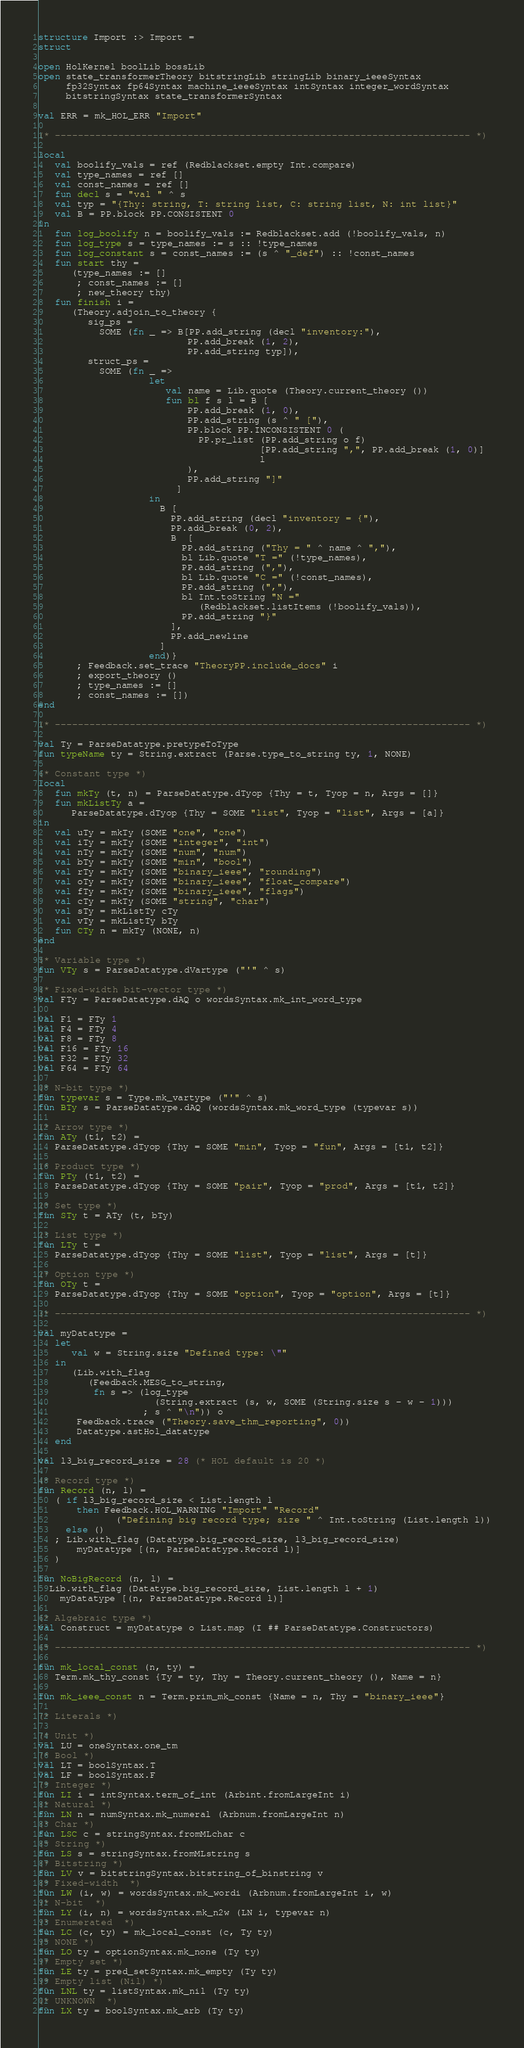Convert code to text. <code><loc_0><loc_0><loc_500><loc_500><_SML_>structure Import :> Import =
struct

open HolKernel boolLib bossLib
open state_transformerTheory bitstringLib stringLib binary_ieeeSyntax
     fp32Syntax fp64Syntax machine_ieeeSyntax intSyntax integer_wordSyntax
     bitstringSyntax state_transformerSyntax

val ERR = mk_HOL_ERR "Import"

(* ------------------------------------------------------------------------ *)

local
   val boolify_vals = ref (Redblackset.empty Int.compare)
   val type_names = ref []
   val const_names = ref []
   fun decl s = "val " ^ s
   val typ = "{Thy: string, T: string list, C: string list, N: int list}"
   val B = PP.block PP.CONSISTENT 0
in
   fun log_boolify n = boolify_vals := Redblackset.add (!boolify_vals, n)
   fun log_type s = type_names := s :: !type_names
   fun log_constant s = const_names := (s ^ "_def") :: !const_names
   fun start thy =
      (type_names := []
       ; const_names := []
       ; new_theory thy)
   fun finish i =
      (Theory.adjoin_to_theory {
         sig_ps =
           SOME (fn _ => B[PP.add_string (decl "inventory:"),
                           PP.add_break (1, 2),
                           PP.add_string typ]),
         struct_ps =
           SOME (fn _ =>
                    let
                       val name = Lib.quote (Theory.current_theory ())
                       fun bl f s l = B [
                           PP.add_break (1, 0),
                           PP.add_string (s ^ " ["),
                           PP.block PP.INCONSISTENT 0 (
                             PP.pr_list (PP.add_string o f)
                                        [PP.add_string ",", PP.add_break (1, 0)]
                                        l
                           ),
                           PP.add_string "]"
                         ]
                    in
                      B [
                        PP.add_string (decl "inventory = {"),
                        PP.add_break (0, 2),
                        B  [
                          PP.add_string ("Thy = " ^ name ^ ","),
                          bl Lib.quote "T =" (!type_names),
                          PP.add_string (","),
                          bl Lib.quote "C =" (!const_names),
                          PP.add_string (","),
                          bl Int.toString "N ="
                             (Redblackset.listItems (!boolify_vals)),
                          PP.add_string "}"
                        ],
                        PP.add_newline
                      ]
                    end)}
       ; Feedback.set_trace "TheoryPP.include_docs" i
       ; export_theory ()
       ; type_names := []
       ; const_names := [])
end

(* ------------------------------------------------------------------------ *)

val Ty = ParseDatatype.pretypeToType
fun typeName ty = String.extract (Parse.type_to_string ty, 1, NONE)

(* Constant type *)
local
   fun mkTy (t, n) = ParseDatatype.dTyop {Thy = t, Tyop = n, Args = []}
   fun mkListTy a =
      ParseDatatype.dTyop {Thy = SOME "list", Tyop = "list", Args = [a]}
in
   val uTy = mkTy (SOME "one", "one")
   val iTy = mkTy (SOME "integer", "int")
   val nTy = mkTy (SOME "num", "num")
   val bTy = mkTy (SOME "min", "bool")
   val rTy = mkTy (SOME "binary_ieee", "rounding")
   val oTy = mkTy (SOME "binary_ieee", "float_compare")
   val fTy = mkTy (SOME "binary_ieee", "flags")
   val cTy = mkTy (SOME "string", "char")
   val sTy = mkListTy cTy
   val vTy = mkListTy bTy
   fun CTy n = mkTy (NONE, n)
end

(* Variable type *)
fun VTy s = ParseDatatype.dVartype ("'" ^ s)

(* Fixed-width bit-vector type *)
val FTy = ParseDatatype.dAQ o wordsSyntax.mk_int_word_type

val F1 = FTy 1
val F4 = FTy 4
val F8 = FTy 8
val F16 = FTy 16
val F32 = FTy 32
val F64 = FTy 64

(* N-bit type *)
fun typevar s = Type.mk_vartype ("'" ^ s)
fun BTy s = ParseDatatype.dAQ (wordsSyntax.mk_word_type (typevar s))

(* Arrow type *)
fun ATy (t1, t2) =
   ParseDatatype.dTyop {Thy = SOME "min", Tyop = "fun", Args = [t1, t2]}

(* Product type *)
fun PTy (t1, t2) =
   ParseDatatype.dTyop {Thy = SOME "pair", Tyop = "prod", Args = [t1, t2]}

(* Set type *)
fun STy t = ATy (t, bTy)

(* List type *)
fun LTy t =
   ParseDatatype.dTyop {Thy = SOME "list", Tyop = "list", Args = [t]}

(* Option type *)
fun OTy t =
   ParseDatatype.dTyop {Thy = SOME "option", Tyop = "option", Args = [t]}

(* ------------------------------------------------------------------------ *)

val myDatatype =
   let
      val w = String.size "Defined type: \""
   in
      (Lib.with_flag
         (Feedback.MESG_to_string,
          fn s => (log_type
                     (String.extract (s, w, SOME (String.size s - w - 1)))
                   ; s ^ "\n")) o
       Feedback.trace ("Theory.save_thm_reporting", 0))
       Datatype.astHol_datatype
   end

val l3_big_record_size = 28 (* HOL default is 20 *)

(* Record type *)
fun Record (n, l) =
   ( if l3_big_record_size < List.length l
       then Feedback.HOL_WARNING "Import" "Record"
              ("Defining big record type; size " ^ Int.toString (List.length l))
     else ()
   ; Lib.with_flag (Datatype.big_record_size, l3_big_record_size)
       myDatatype [(n, ParseDatatype.Record l)]
   )

fun NoBigRecord (n, l) =
  Lib.with_flag (Datatype.big_record_size, List.length l + 1)
    myDatatype [(n, ParseDatatype.Record l)]

(* Algebraic type *)
val Construct = myDatatype o List.map (I ## ParseDatatype.Constructors)

(* ------------------------------------------------------------------------ *)

fun mk_local_const (n, ty) =
   Term.mk_thy_const {Ty = ty, Thy = Theory.current_theory (), Name = n}

fun mk_ieee_const n = Term.prim_mk_const {Name = n, Thy = "binary_ieee"}

(* Literals *)

(* Unit *)
val LU = oneSyntax.one_tm
(* Bool *)
val LT = boolSyntax.T
val LF = boolSyntax.F
(* Integer *)
fun LI i = intSyntax.term_of_int (Arbint.fromLargeInt i)
(* Natural *)
fun LN n = numSyntax.mk_numeral (Arbnum.fromLargeInt n)
(* Char *)
fun LSC c = stringSyntax.fromMLchar c
(* String *)
fun LS s = stringSyntax.fromMLstring s
(* Bitstring *)
fun LV v = bitstringSyntax.bitstring_of_binstring v
(* Fixed-width  *)
fun LW (i, w) = wordsSyntax.mk_wordi (Arbnum.fromLargeInt i, w)
(* N-bit  *)
fun LY (i, n) = wordsSyntax.mk_n2w (LN i, typevar n)
(* Enumerated  *)
fun LC (c, ty) = mk_local_const (c, Ty ty)
(* NONE *)
fun LO ty = optionSyntax.mk_none (Ty ty)
(* Empty set *)
fun LE ty = pred_setSyntax.mk_empty (Ty ty)
(* Empty list (Nil) *)
fun LNL ty = listSyntax.mk_nil (Ty ty)
(* UNKNOWN  *)
fun LX ty = boolSyntax.mk_arb (Ty ty)
</code> 